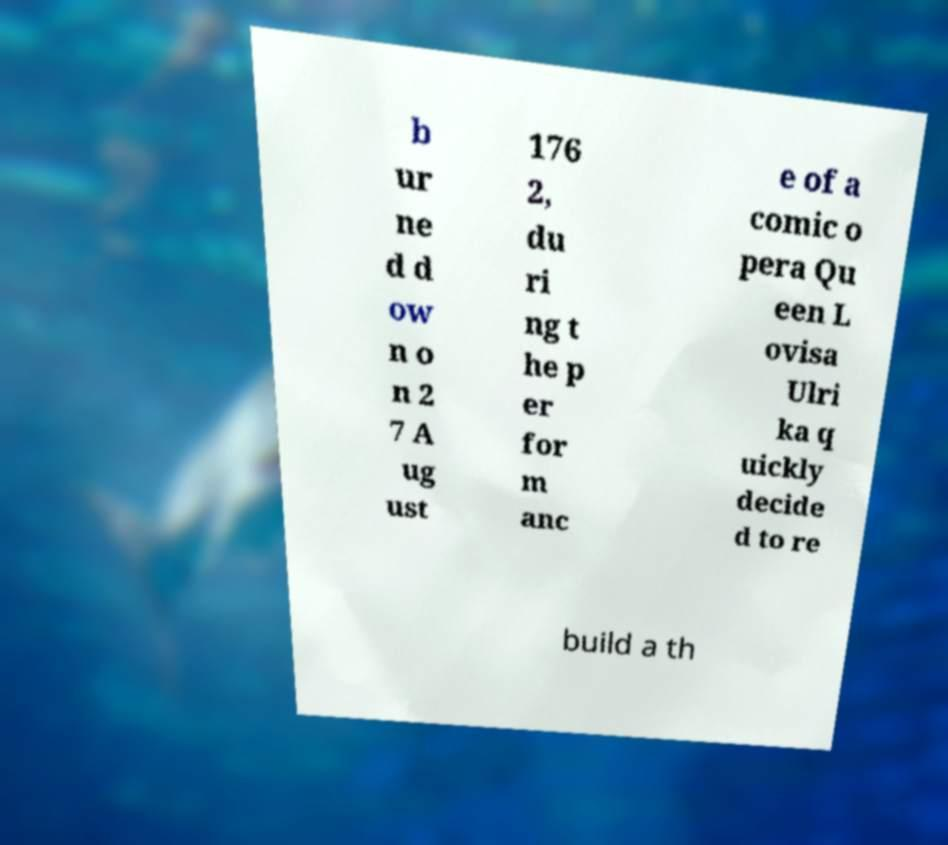There's text embedded in this image that I need extracted. Can you transcribe it verbatim? b ur ne d d ow n o n 2 7 A ug ust 176 2, du ri ng t he p er for m anc e of a comic o pera Qu een L ovisa Ulri ka q uickly decide d to re build a th 